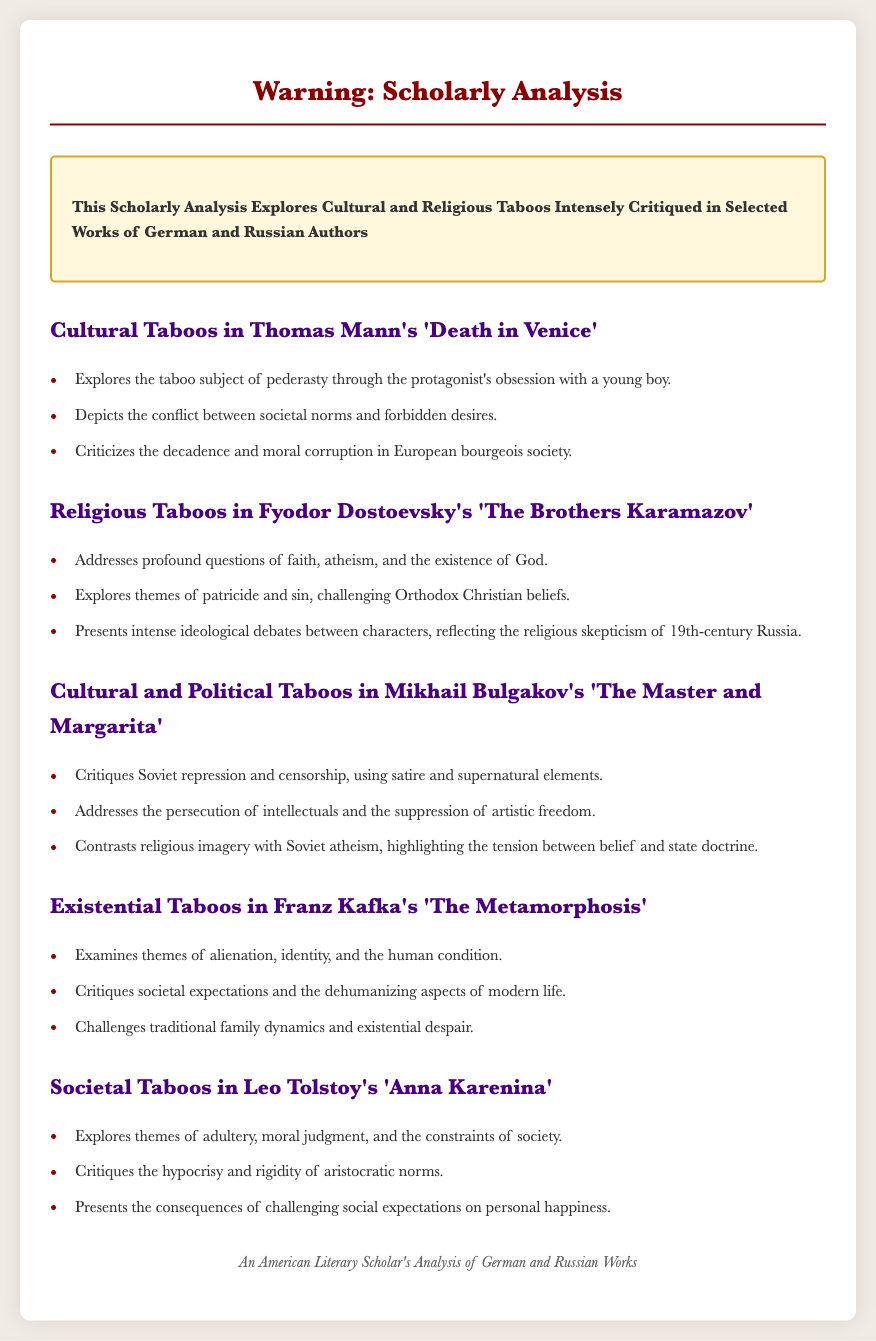what is the title of the document? The title of the document appears in the header, clearly stating the subject of the warning.
Answer: Warning: Scholarly Analysis which German author is discussed in the context of cultural taboos? The document specifically mentions Thomas Mann in relation to cultural taboos.
Answer: Thomas Mann which Russian work addresses notions of faith and atheism? The document explicitly refers to Fyodor Dostoevsky's 'The Brothers Karamazov' as it explores faith and atheism.
Answer: The Brothers Karamazov what theme is critiqued in Mikhail Bulgakov's 'The Master and Margarita'? The document highlights that societal repression and censorship are major themes critiqued in this work.
Answer: Soviet repression and censorship how many works are analyzed in total? The document lists five distinct works of literature in relation to various taboos, providing a comprehensive analysis.
Answer: Five what is the societal taboo explored in Leo Tolstoy's 'Anna Karenina'? The document identifies adultery as a key societal taboo explored in this literary work.
Answer: Adultery which literary theme is common in Franz Kafka's 'The Metamorphosis'? The document notes that themes of alienation and identity are common in Kafka's work.
Answer: Alienation and identity what is the overall focus of the scholarly analysis? The document emphasizes that the analysis primarily deals with cultural and religious taboos in literature.
Answer: Cultural and religious taboos 